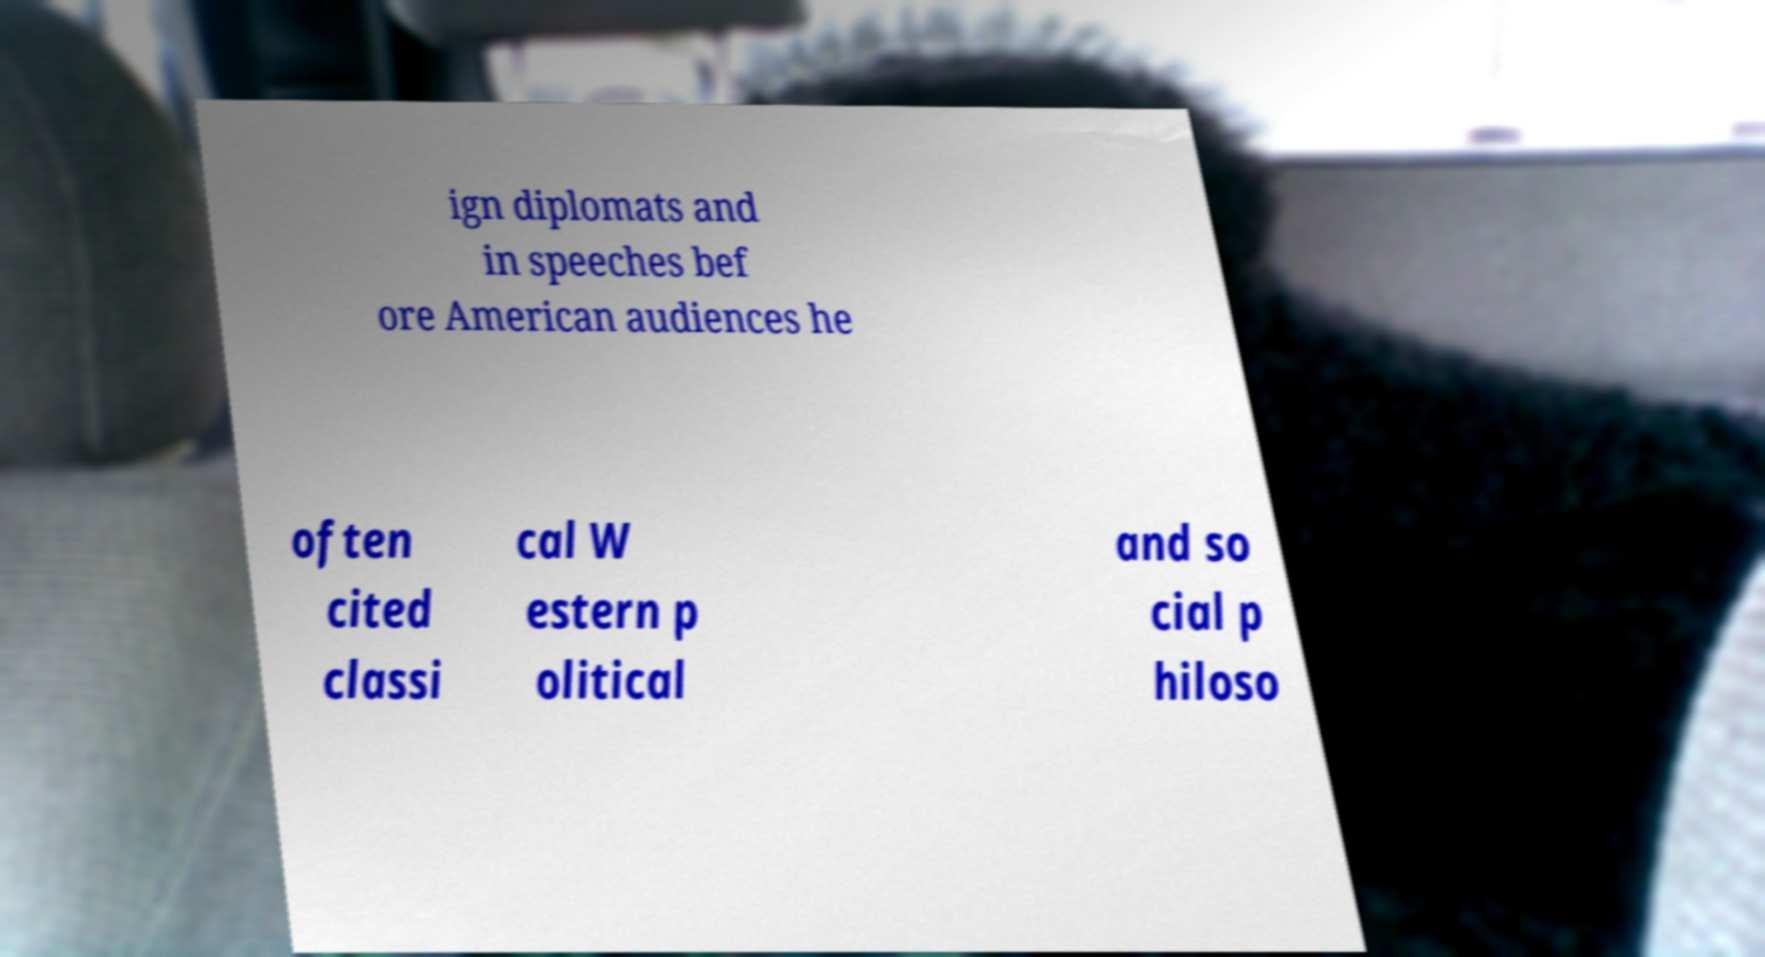For documentation purposes, I need the text within this image transcribed. Could you provide that? ign diplomats and in speeches bef ore American audiences he often cited classi cal W estern p olitical and so cial p hiloso 